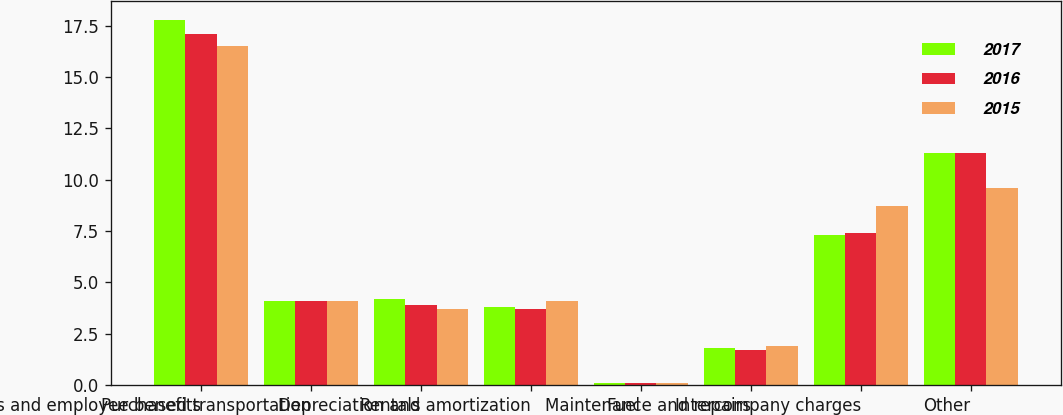Convert chart to OTSL. <chart><loc_0><loc_0><loc_500><loc_500><stacked_bar_chart><ecel><fcel>Salaries and employee benefits<fcel>Purchased transportation<fcel>Rentals<fcel>Depreciation and amortization<fcel>Fuel<fcel>Maintenance and repairs<fcel>Intercompany charges<fcel>Other<nl><fcel>2017<fcel>17.8<fcel>4.1<fcel>4.2<fcel>3.8<fcel>0.1<fcel>1.8<fcel>7.3<fcel>11.3<nl><fcel>2016<fcel>17.1<fcel>4.1<fcel>3.9<fcel>3.7<fcel>0.1<fcel>1.7<fcel>7.4<fcel>11.3<nl><fcel>2015<fcel>16.5<fcel>4.1<fcel>3.7<fcel>4.1<fcel>0.1<fcel>1.9<fcel>8.7<fcel>9.6<nl></chart> 